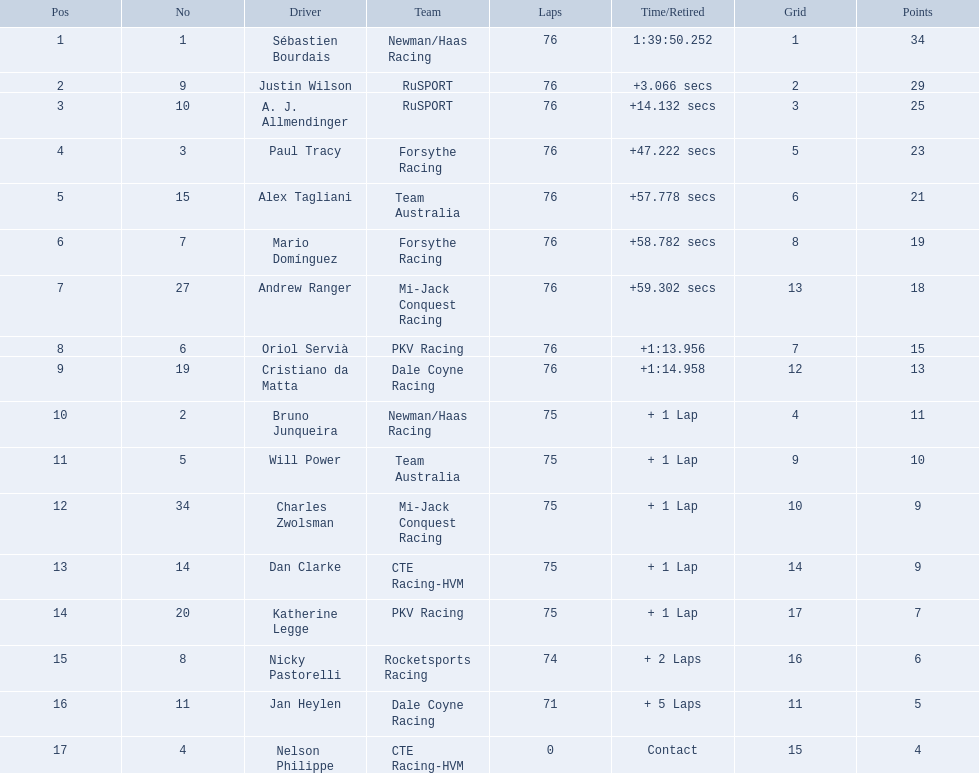Which drivers accomplished all 76 laps? Sébastien Bourdais, Justin Wilson, A. J. Allmendinger, Paul Tracy, Alex Tagliani, Mario Domínguez, Andrew Ranger, Oriol Servià, Cristiano da Matta. Of these drivers, which ones concluded less than a minute behind the leader? Paul Tracy, Alex Tagliani, Mario Domínguez, Andrew Ranger. Of these drivers, which ones wrapped up with a time less than 50 seconds behind the first place? Justin Wilson, A. J. Allmendinger, Paul Tracy. Of these three drivers, who was the last one to finish? Paul Tracy. 